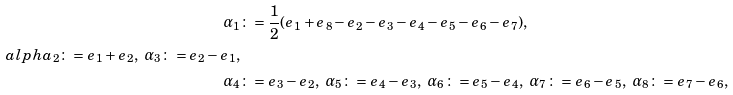<formula> <loc_0><loc_0><loc_500><loc_500>\alpha _ { 1 } & \colon = \frac { 1 } { 2 } ( e _ { 1 } + e _ { 8 } - e _ { 2 } - e _ { 3 } - e _ { 4 } - e _ { 5 } - e _ { 6 } - e _ { 7 } ) , \\ a l p h a _ { 2 } \colon = e _ { 1 } + e _ { 2 } , \ \alpha _ { 3 } \colon = e _ { 2 } - e _ { 1 } , \\ \alpha _ { 4 } & \colon = e _ { 3 } - e _ { 2 } , \ \alpha _ { 5 } \colon = e _ { 4 } - e _ { 3 } , \ \alpha _ { 6 } \colon = e _ { 5 } - e _ { 4 } , \ \alpha _ { 7 } \colon = e _ { 6 } - e _ { 5 } , \ \alpha _ { 8 } \colon = e _ { 7 } - e _ { 6 } ,</formula> 